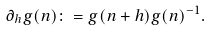Convert formula to latex. <formula><loc_0><loc_0><loc_500><loc_500>\partial _ { h } g ( n ) \colon = g ( n + h ) g ( n ) ^ { - 1 } .</formula> 